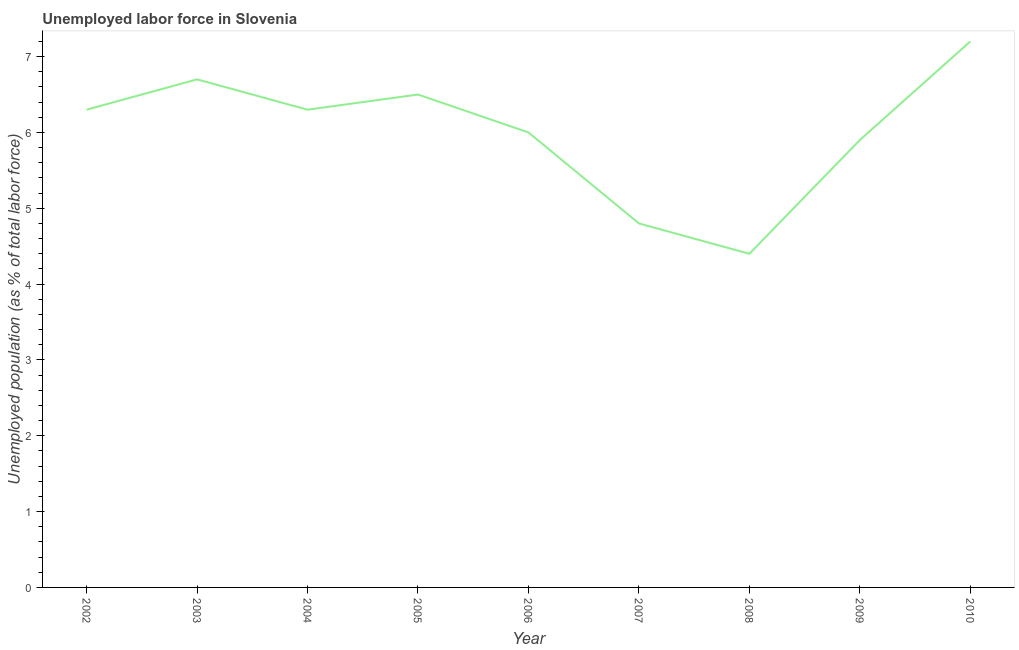What is the total unemployed population in 2004?
Offer a terse response. 6.3. Across all years, what is the maximum total unemployed population?
Your answer should be compact. 7.2. Across all years, what is the minimum total unemployed population?
Ensure brevity in your answer.  4.4. What is the sum of the total unemployed population?
Provide a short and direct response. 54.1. What is the difference between the total unemployed population in 2003 and 2008?
Keep it short and to the point. 2.3. What is the average total unemployed population per year?
Your answer should be compact. 6.01. What is the median total unemployed population?
Your answer should be compact. 6.3. Do a majority of the years between 2009 and 2003 (inclusive) have total unemployed population greater than 3 %?
Your answer should be compact. Yes. What is the ratio of the total unemployed population in 2003 to that in 2009?
Provide a short and direct response. 1.14. Is the sum of the total unemployed population in 2004 and 2010 greater than the maximum total unemployed population across all years?
Make the answer very short. Yes. What is the difference between the highest and the lowest total unemployed population?
Offer a terse response. 2.8. Does the total unemployed population monotonically increase over the years?
Your answer should be compact. No. How many lines are there?
Keep it short and to the point. 1. How many years are there in the graph?
Give a very brief answer. 9. Are the values on the major ticks of Y-axis written in scientific E-notation?
Offer a very short reply. No. Does the graph contain any zero values?
Offer a terse response. No. What is the title of the graph?
Your response must be concise. Unemployed labor force in Slovenia. What is the label or title of the X-axis?
Your answer should be very brief. Year. What is the label or title of the Y-axis?
Your response must be concise. Unemployed population (as % of total labor force). What is the Unemployed population (as % of total labor force) of 2002?
Provide a short and direct response. 6.3. What is the Unemployed population (as % of total labor force) in 2003?
Keep it short and to the point. 6.7. What is the Unemployed population (as % of total labor force) in 2004?
Offer a terse response. 6.3. What is the Unemployed population (as % of total labor force) in 2006?
Provide a succinct answer. 6. What is the Unemployed population (as % of total labor force) of 2007?
Offer a terse response. 4.8. What is the Unemployed population (as % of total labor force) of 2008?
Ensure brevity in your answer.  4.4. What is the Unemployed population (as % of total labor force) of 2009?
Offer a terse response. 5.9. What is the Unemployed population (as % of total labor force) of 2010?
Ensure brevity in your answer.  7.2. What is the difference between the Unemployed population (as % of total labor force) in 2002 and 2004?
Make the answer very short. 0. What is the difference between the Unemployed population (as % of total labor force) in 2002 and 2005?
Provide a succinct answer. -0.2. What is the difference between the Unemployed population (as % of total labor force) in 2002 and 2007?
Make the answer very short. 1.5. What is the difference between the Unemployed population (as % of total labor force) in 2002 and 2008?
Provide a short and direct response. 1.9. What is the difference between the Unemployed population (as % of total labor force) in 2002 and 2009?
Provide a succinct answer. 0.4. What is the difference between the Unemployed population (as % of total labor force) in 2002 and 2010?
Keep it short and to the point. -0.9. What is the difference between the Unemployed population (as % of total labor force) in 2003 and 2006?
Make the answer very short. 0.7. What is the difference between the Unemployed population (as % of total labor force) in 2003 and 2007?
Make the answer very short. 1.9. What is the difference between the Unemployed population (as % of total labor force) in 2003 and 2008?
Keep it short and to the point. 2.3. What is the difference between the Unemployed population (as % of total labor force) in 2003 and 2010?
Offer a very short reply. -0.5. What is the difference between the Unemployed population (as % of total labor force) in 2004 and 2006?
Your response must be concise. 0.3. What is the difference between the Unemployed population (as % of total labor force) in 2004 and 2007?
Ensure brevity in your answer.  1.5. What is the difference between the Unemployed population (as % of total labor force) in 2004 and 2008?
Your answer should be compact. 1.9. What is the difference between the Unemployed population (as % of total labor force) in 2004 and 2009?
Ensure brevity in your answer.  0.4. What is the difference between the Unemployed population (as % of total labor force) in 2005 and 2006?
Give a very brief answer. 0.5. What is the difference between the Unemployed population (as % of total labor force) in 2005 and 2009?
Provide a succinct answer. 0.6. What is the difference between the Unemployed population (as % of total labor force) in 2005 and 2010?
Offer a very short reply. -0.7. What is the difference between the Unemployed population (as % of total labor force) in 2006 and 2007?
Give a very brief answer. 1.2. What is the difference between the Unemployed population (as % of total labor force) in 2006 and 2009?
Keep it short and to the point. 0.1. What is the difference between the Unemployed population (as % of total labor force) in 2006 and 2010?
Provide a short and direct response. -1.2. What is the difference between the Unemployed population (as % of total labor force) in 2009 and 2010?
Provide a short and direct response. -1.3. What is the ratio of the Unemployed population (as % of total labor force) in 2002 to that in 2003?
Your answer should be compact. 0.94. What is the ratio of the Unemployed population (as % of total labor force) in 2002 to that in 2004?
Ensure brevity in your answer.  1. What is the ratio of the Unemployed population (as % of total labor force) in 2002 to that in 2005?
Offer a terse response. 0.97. What is the ratio of the Unemployed population (as % of total labor force) in 2002 to that in 2007?
Your answer should be compact. 1.31. What is the ratio of the Unemployed population (as % of total labor force) in 2002 to that in 2008?
Provide a short and direct response. 1.43. What is the ratio of the Unemployed population (as % of total labor force) in 2002 to that in 2009?
Your answer should be very brief. 1.07. What is the ratio of the Unemployed population (as % of total labor force) in 2002 to that in 2010?
Offer a very short reply. 0.88. What is the ratio of the Unemployed population (as % of total labor force) in 2003 to that in 2004?
Ensure brevity in your answer.  1.06. What is the ratio of the Unemployed population (as % of total labor force) in 2003 to that in 2005?
Make the answer very short. 1.03. What is the ratio of the Unemployed population (as % of total labor force) in 2003 to that in 2006?
Provide a short and direct response. 1.12. What is the ratio of the Unemployed population (as % of total labor force) in 2003 to that in 2007?
Make the answer very short. 1.4. What is the ratio of the Unemployed population (as % of total labor force) in 2003 to that in 2008?
Provide a short and direct response. 1.52. What is the ratio of the Unemployed population (as % of total labor force) in 2003 to that in 2009?
Ensure brevity in your answer.  1.14. What is the ratio of the Unemployed population (as % of total labor force) in 2004 to that in 2005?
Ensure brevity in your answer.  0.97. What is the ratio of the Unemployed population (as % of total labor force) in 2004 to that in 2006?
Provide a succinct answer. 1.05. What is the ratio of the Unemployed population (as % of total labor force) in 2004 to that in 2007?
Offer a terse response. 1.31. What is the ratio of the Unemployed population (as % of total labor force) in 2004 to that in 2008?
Give a very brief answer. 1.43. What is the ratio of the Unemployed population (as % of total labor force) in 2004 to that in 2009?
Offer a terse response. 1.07. What is the ratio of the Unemployed population (as % of total labor force) in 2005 to that in 2006?
Your answer should be compact. 1.08. What is the ratio of the Unemployed population (as % of total labor force) in 2005 to that in 2007?
Provide a succinct answer. 1.35. What is the ratio of the Unemployed population (as % of total labor force) in 2005 to that in 2008?
Offer a very short reply. 1.48. What is the ratio of the Unemployed population (as % of total labor force) in 2005 to that in 2009?
Provide a succinct answer. 1.1. What is the ratio of the Unemployed population (as % of total labor force) in 2005 to that in 2010?
Provide a succinct answer. 0.9. What is the ratio of the Unemployed population (as % of total labor force) in 2006 to that in 2007?
Your response must be concise. 1.25. What is the ratio of the Unemployed population (as % of total labor force) in 2006 to that in 2008?
Your answer should be very brief. 1.36. What is the ratio of the Unemployed population (as % of total labor force) in 2006 to that in 2010?
Ensure brevity in your answer.  0.83. What is the ratio of the Unemployed population (as % of total labor force) in 2007 to that in 2008?
Ensure brevity in your answer.  1.09. What is the ratio of the Unemployed population (as % of total labor force) in 2007 to that in 2009?
Keep it short and to the point. 0.81. What is the ratio of the Unemployed population (as % of total labor force) in 2007 to that in 2010?
Make the answer very short. 0.67. What is the ratio of the Unemployed population (as % of total labor force) in 2008 to that in 2009?
Ensure brevity in your answer.  0.75. What is the ratio of the Unemployed population (as % of total labor force) in 2008 to that in 2010?
Provide a succinct answer. 0.61. What is the ratio of the Unemployed population (as % of total labor force) in 2009 to that in 2010?
Offer a very short reply. 0.82. 